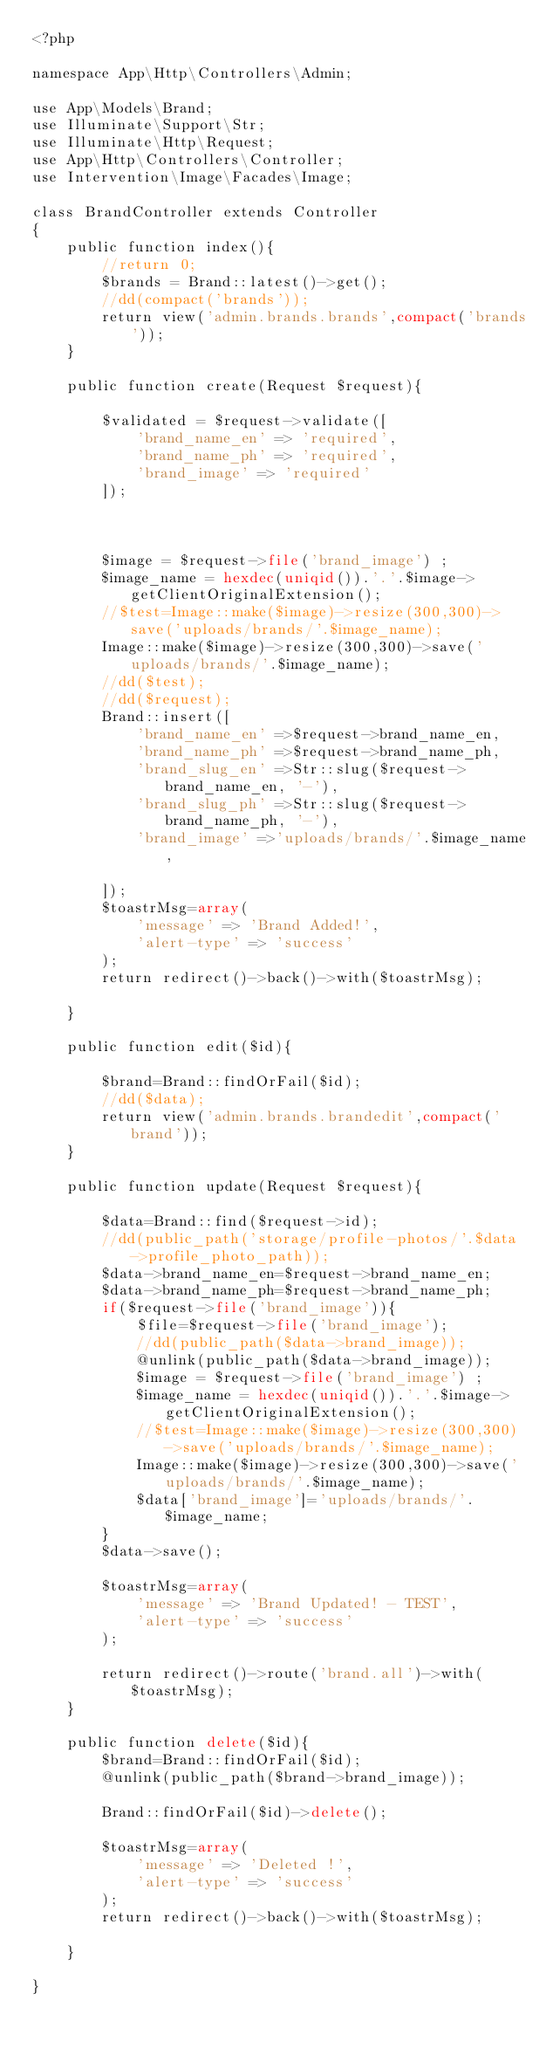Convert code to text. <code><loc_0><loc_0><loc_500><loc_500><_PHP_><?php

namespace App\Http\Controllers\Admin;

use App\Models\Brand;
use Illuminate\Support\Str;
use Illuminate\Http\Request;
use App\Http\Controllers\Controller;
use Intervention\Image\Facades\Image;

class BrandController extends Controller
{
    public function index(){
        //return 0;        
        $brands = Brand::latest()->get();
        //dd(compact('brands'));
        return view('admin.brands.brands',compact('brands'));
    }

    public function create(Request $request){

        $validated = $request->validate([
            'brand_name_en' => 'required',            
            'brand_name_ph' => 'required',    
            'brand_image' => 'required'
        ]);

        

        $image = $request->file('brand_image') ;
        $image_name = hexdec(uniqid()).'.'.$image->getClientOriginalExtension();
        //$test=Image::make($image)->resize(300,300)->save('uploads/brands/'.$image_name);
        Image::make($image)->resize(300,300)->save('uploads/brands/'.$image_name);
        //dd($test);
        //dd($request);
        Brand::insert([
            'brand_name_en' =>$request->brand_name_en,
            'brand_name_ph' =>$request->brand_name_ph,
            'brand_slug_en' =>Str::slug($request->brand_name_en, '-'),
            'brand_slug_ph' =>Str::slug($request->brand_name_ph, '-'),
            'brand_image' =>'uploads/brands/'.$image_name,
            
        ]);
        $toastrMsg=array(
            'message' => 'Brand Added!',
            'alert-type' => 'success'
        );
        return redirect()->back()->with($toastrMsg);

    }

    public function edit($id){
        
        $brand=Brand::findOrFail($id);
        //dd($data);
        return view('admin.brands.brandedit',compact('brand'));
    }

    public function update(Request $request){

        $data=Brand::find($request->id);
        //dd(public_path('storage/profile-photos/'.$data->profile_photo_path));
        $data->brand_name_en=$request->brand_name_en;
        $data->brand_name_ph=$request->brand_name_ph;
        if($request->file('brand_image')){
            $file=$request->file('brand_image');
            //dd(public_path($data->brand_image));
            @unlink(public_path($data->brand_image));
            $image = $request->file('brand_image') ;
            $image_name = hexdec(uniqid()).'.'.$image->getClientOriginalExtension();
            //$test=Image::make($image)->resize(300,300)->save('uploads/brands/'.$image_name);
            Image::make($image)->resize(300,300)->save('uploads/brands/'.$image_name);
            $data['brand_image']='uploads/brands/'.$image_name;  
        }
        $data->save();

        $toastrMsg=array(
            'message' => 'Brand Updated! - TEST',
            'alert-type' => 'success'
        );

        return redirect()->route('brand.all')->with($toastrMsg);
    }

    public function delete($id){
        $brand=Brand::findOrFail($id);
        @unlink(public_path($brand->brand_image));

        Brand::findOrFail($id)->delete();

        $toastrMsg=array(
            'message' => 'Deleted !',
            'alert-type' => 'success'
        );
        return redirect()->back()->with($toastrMsg);
        
    }

}
</code> 